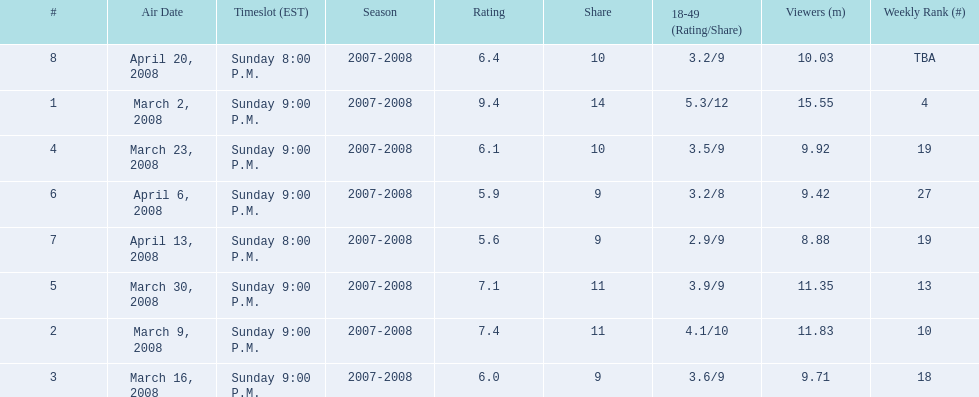What episode had the highest rating? March 2, 2008. 